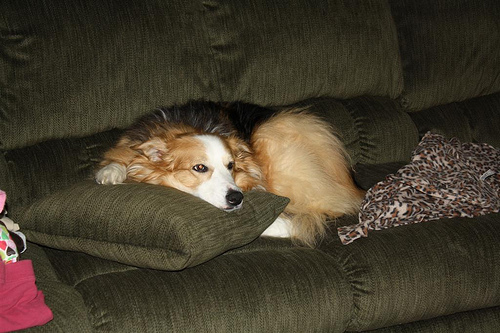<image>
Is the dog next to the couch? No. The dog is not positioned next to the couch. They are located in different areas of the scene. 